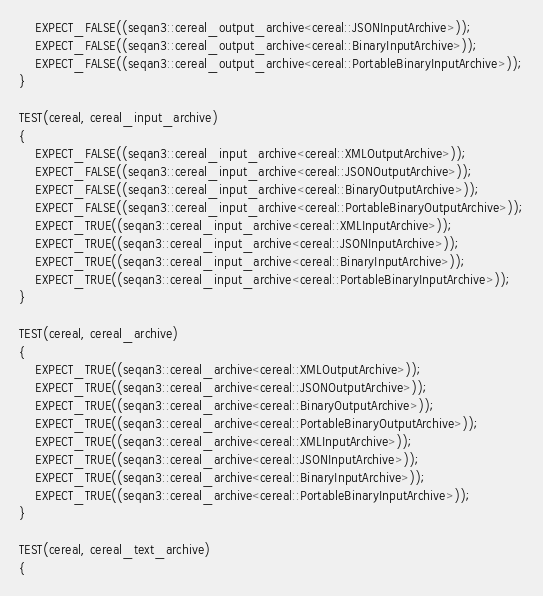Convert code to text. <code><loc_0><loc_0><loc_500><loc_500><_C++_>    EXPECT_FALSE((seqan3::cereal_output_archive<cereal::JSONInputArchive>));
    EXPECT_FALSE((seqan3::cereal_output_archive<cereal::BinaryInputArchive>));
    EXPECT_FALSE((seqan3::cereal_output_archive<cereal::PortableBinaryInputArchive>));
}

TEST(cereal, cereal_input_archive)
{
    EXPECT_FALSE((seqan3::cereal_input_archive<cereal::XMLOutputArchive>));
    EXPECT_FALSE((seqan3::cereal_input_archive<cereal::JSONOutputArchive>));
    EXPECT_FALSE((seqan3::cereal_input_archive<cereal::BinaryOutputArchive>));
    EXPECT_FALSE((seqan3::cereal_input_archive<cereal::PortableBinaryOutputArchive>));
    EXPECT_TRUE((seqan3::cereal_input_archive<cereal::XMLInputArchive>));
    EXPECT_TRUE((seqan3::cereal_input_archive<cereal::JSONInputArchive>));
    EXPECT_TRUE((seqan3::cereal_input_archive<cereal::BinaryInputArchive>));
    EXPECT_TRUE((seqan3::cereal_input_archive<cereal::PortableBinaryInputArchive>));
}

TEST(cereal, cereal_archive)
{
    EXPECT_TRUE((seqan3::cereal_archive<cereal::XMLOutputArchive>));
    EXPECT_TRUE((seqan3::cereal_archive<cereal::JSONOutputArchive>));
    EXPECT_TRUE((seqan3::cereal_archive<cereal::BinaryOutputArchive>));
    EXPECT_TRUE((seqan3::cereal_archive<cereal::PortableBinaryOutputArchive>));
    EXPECT_TRUE((seqan3::cereal_archive<cereal::XMLInputArchive>));
    EXPECT_TRUE((seqan3::cereal_archive<cereal::JSONInputArchive>));
    EXPECT_TRUE((seqan3::cereal_archive<cereal::BinaryInputArchive>));
    EXPECT_TRUE((seqan3::cereal_archive<cereal::PortableBinaryInputArchive>));
}

TEST(cereal, cereal_text_archive)
{</code> 